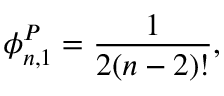<formula> <loc_0><loc_0><loc_500><loc_500>\phi _ { n , 1 } ^ { P } = \frac { 1 } { 2 ( n - 2 ) ! } ,</formula> 